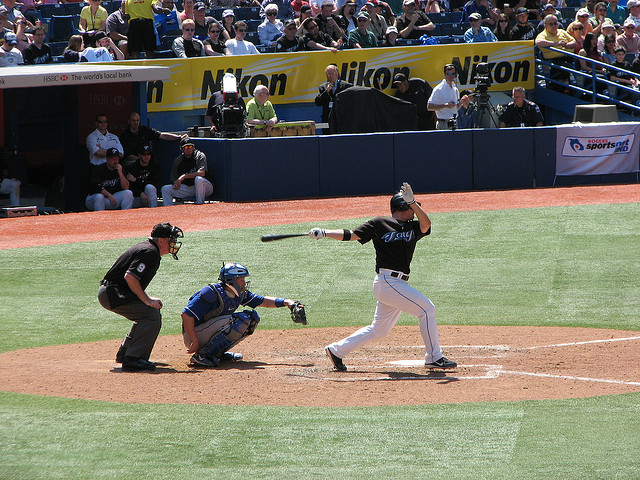Identify the text displayed in this image. Nikon Nikon Nikon faiy n The 